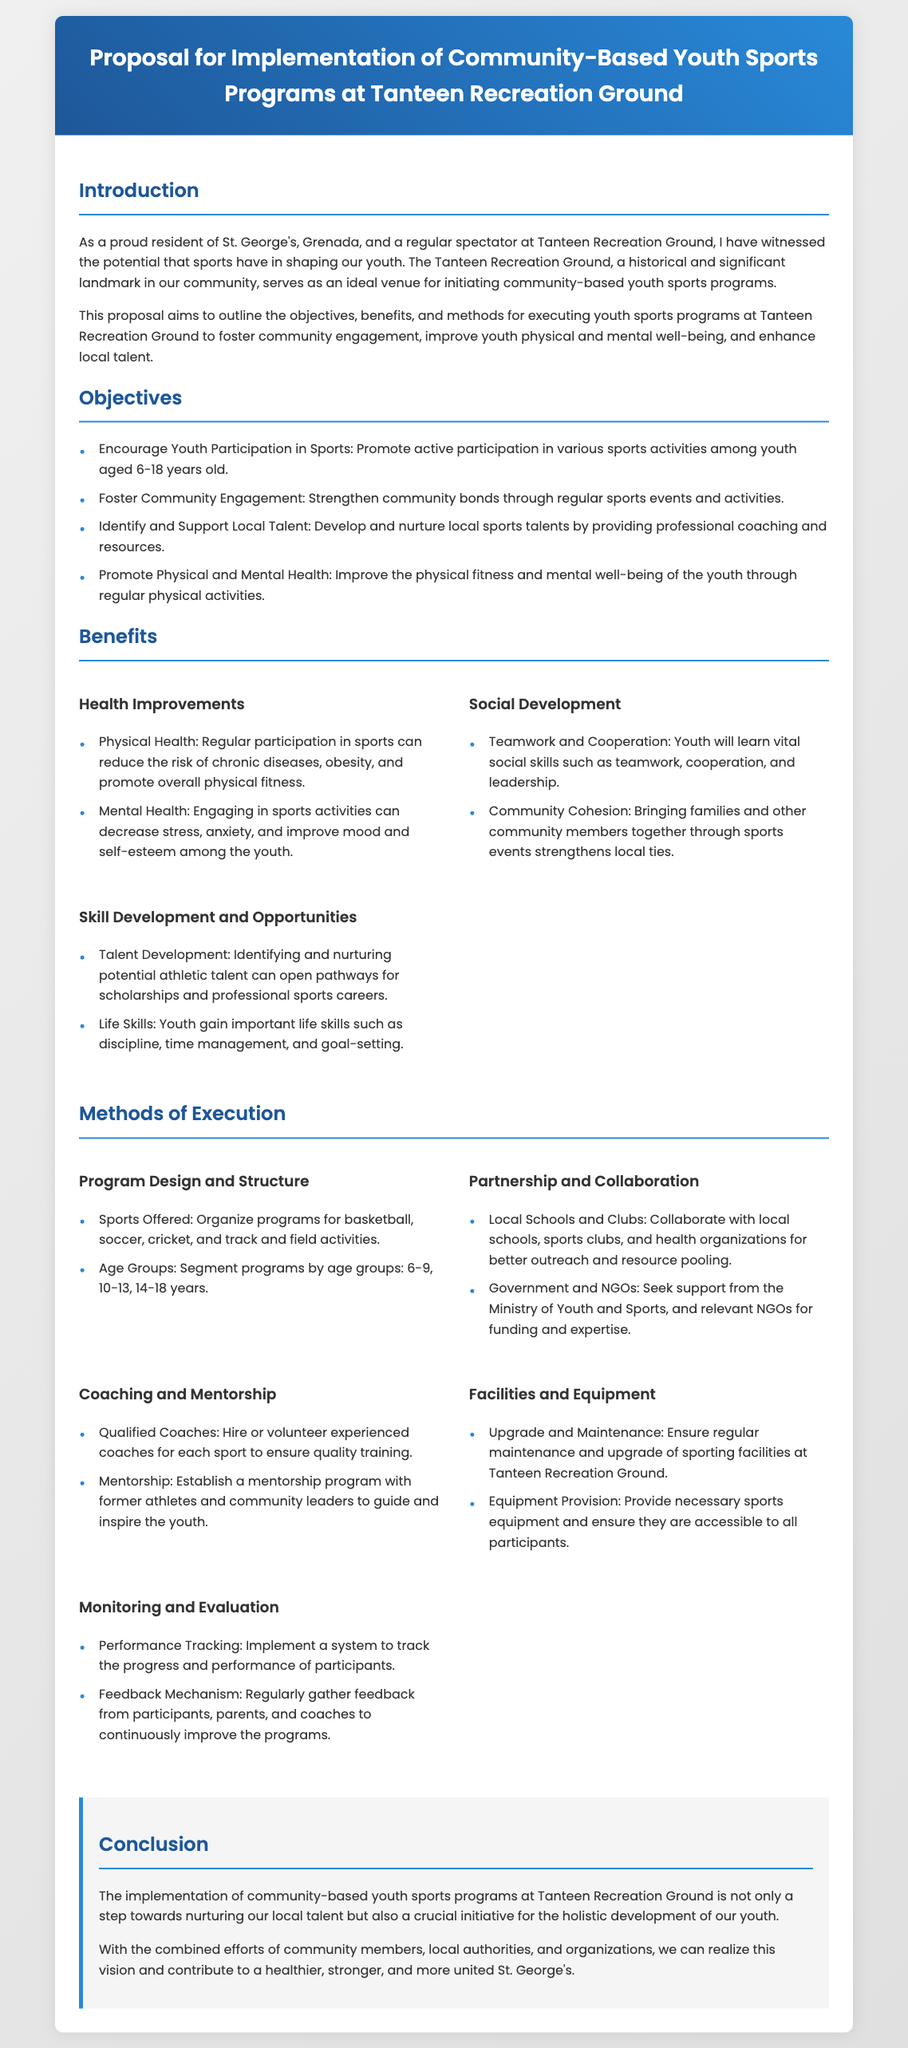What is the primary venue for the youth sports programs? The proposal outlines the Tanteen Recreation Ground as the primary venue for the programs.
Answer: Tanteen Recreation Ground What age group is targeted for participation in the sports programs? The proposal specifies the target age range for participants is youth aged 6-18 years old.
Answer: 6-18 years old What is one objective of the proposed programs? An objective mentioned is to encourage active participation in various sports activities among youth.
Answer: Encourage Youth Participation in Sports Which government body is mentioned for partnership support? The proposal states that the Ministry of Youth and Sports is relevant for seeking support.
Answer: Ministry of Youth and Sports What is one method of execution for the programs? The document lists organizing programs for various sports as one method of execution.
Answer: Organize programs for basketball, soccer, cricket, and track and field activities Name one benefit related to mental health from the proposed programs. The proposal mentions that engaging in sports activities can decrease stress and anxiety.
Answer: Decrease stress What is emphasized as a needed resource for coaches in the programs? The proposal emphasizes hiring or volunteering experienced coaches as a necessary resource.
Answer: Qualified Coaches How many types of benefits are listed in the proposal? The proposal outlines three types of benefits related to health improvements, social development, and skill development.
Answer: Three types What is the conclusion of the proposal? The conclusion highlights that implementing these programs contributes to a healthier and stronger community.
Answer: Contribute to a healthier, stronger, and more united St. George's 